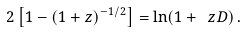Convert formula to latex. <formula><loc_0><loc_0><loc_500><loc_500>2 \left [ 1 - ( 1 + z ) ^ { - 1 / 2 } \right ] = \ln ( 1 + \ z D ) \, .</formula> 